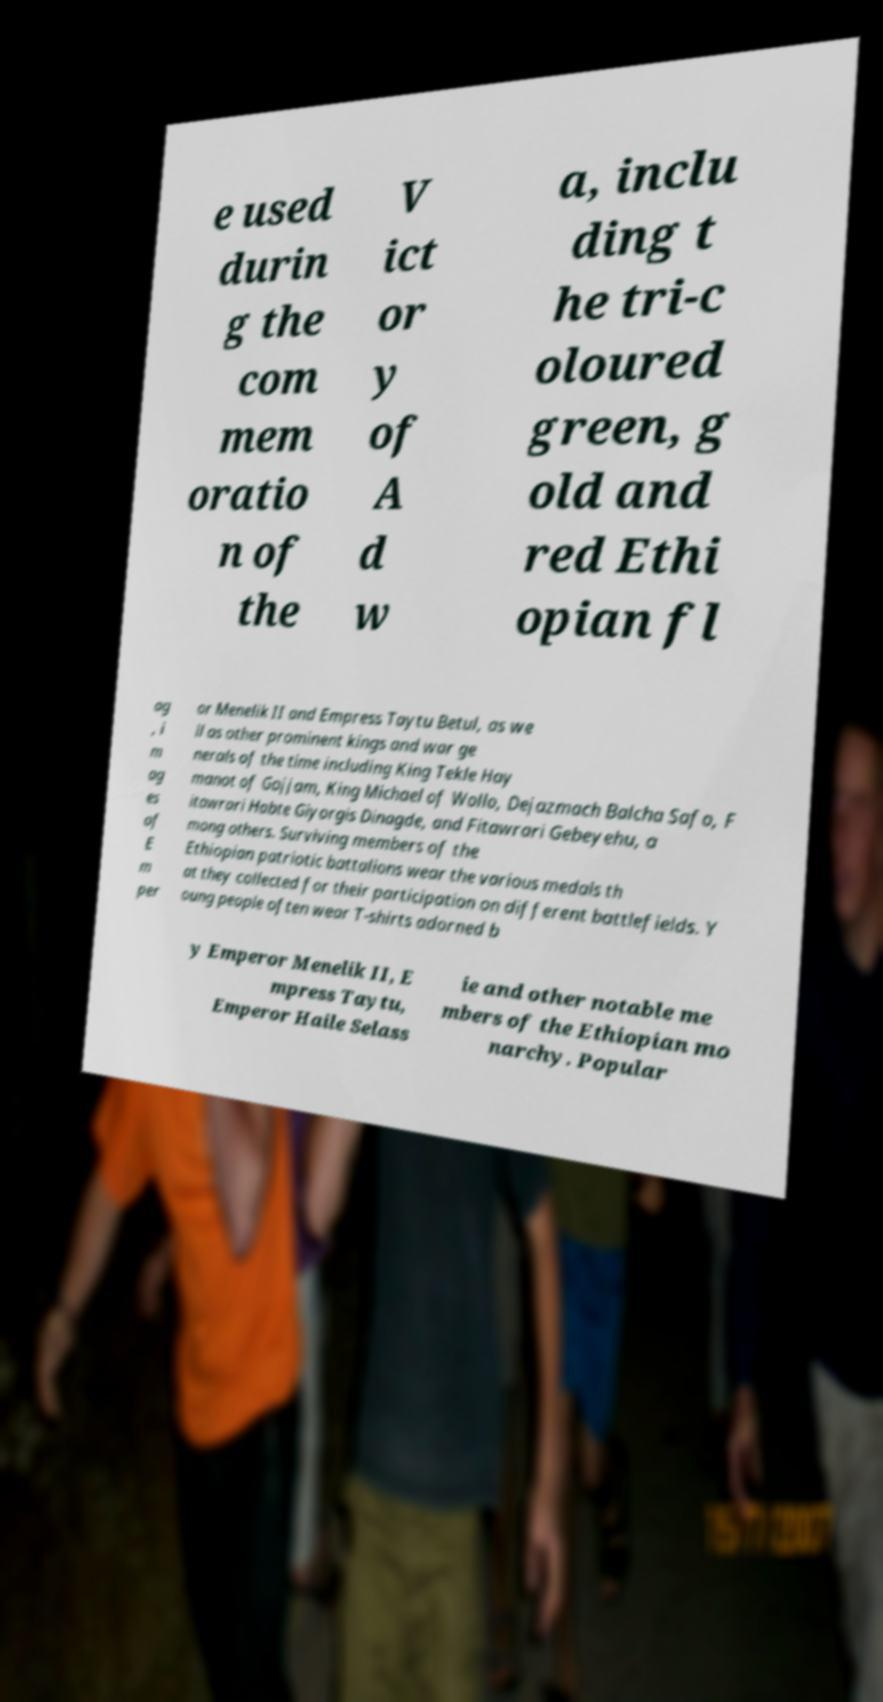Could you assist in decoding the text presented in this image and type it out clearly? e used durin g the com mem oratio n of the V ict or y of A d w a, inclu ding t he tri-c oloured green, g old and red Ethi opian fl ag , i m ag es of E m per or Menelik II and Empress Taytu Betul, as we ll as other prominent kings and war ge nerals of the time including King Tekle Hay manot of Gojjam, King Michael of Wollo, Dejazmach Balcha Safo, F itawrari Habte Giyorgis Dinagde, and Fitawrari Gebeyehu, a mong others. Surviving members of the Ethiopian patriotic battalions wear the various medals th at they collected for their participation on different battlefields. Y oung people often wear T-shirts adorned b y Emperor Menelik II, E mpress Taytu, Emperor Haile Selass ie and other notable me mbers of the Ethiopian mo narchy. Popular 